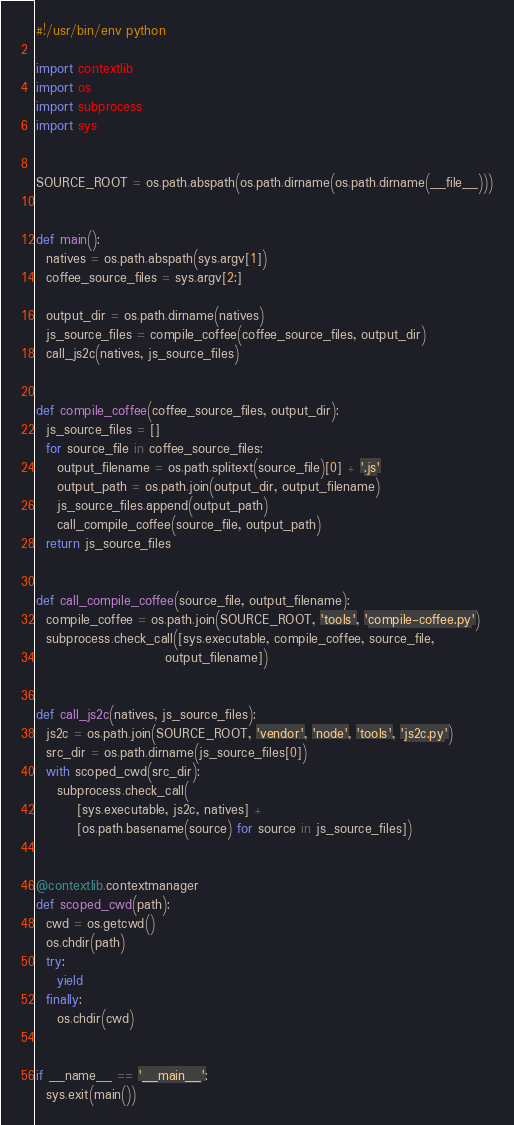Convert code to text. <code><loc_0><loc_0><loc_500><loc_500><_Python_>#!/usr/bin/env python

import contextlib
import os
import subprocess
import sys


SOURCE_ROOT = os.path.abspath(os.path.dirname(os.path.dirname(__file__)))


def main():
  natives = os.path.abspath(sys.argv[1])
  coffee_source_files = sys.argv[2:]

  output_dir = os.path.dirname(natives)
  js_source_files = compile_coffee(coffee_source_files, output_dir)
  call_js2c(natives, js_source_files)


def compile_coffee(coffee_source_files, output_dir):
  js_source_files = []
  for source_file in coffee_source_files:
    output_filename = os.path.splitext(source_file)[0] + '.js'
    output_path = os.path.join(output_dir, output_filename)
    js_source_files.append(output_path)
    call_compile_coffee(source_file, output_path)
  return js_source_files


def call_compile_coffee(source_file, output_filename):
  compile_coffee = os.path.join(SOURCE_ROOT, 'tools', 'compile-coffee.py')
  subprocess.check_call([sys.executable, compile_coffee, source_file,
                         output_filename])


def call_js2c(natives, js_source_files):
  js2c = os.path.join(SOURCE_ROOT, 'vendor', 'node', 'tools', 'js2c.py')
  src_dir = os.path.dirname(js_source_files[0])
  with scoped_cwd(src_dir):
    subprocess.check_call(
        [sys.executable, js2c, natives] +
        [os.path.basename(source) for source in js_source_files])


@contextlib.contextmanager
def scoped_cwd(path):
  cwd = os.getcwd()
  os.chdir(path)
  try:
    yield
  finally:
    os.chdir(cwd)


if __name__ == '__main__':
  sys.exit(main())
</code> 